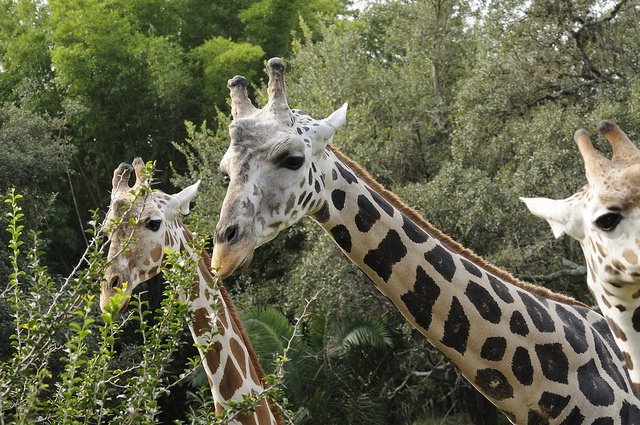Describe the objects in this image and their specific colors. I can see giraffe in olive, black, darkgray, and gray tones, giraffe in olive, darkgray, gray, and tan tones, and giraffe in olive, ivory, darkgray, and tan tones in this image. 